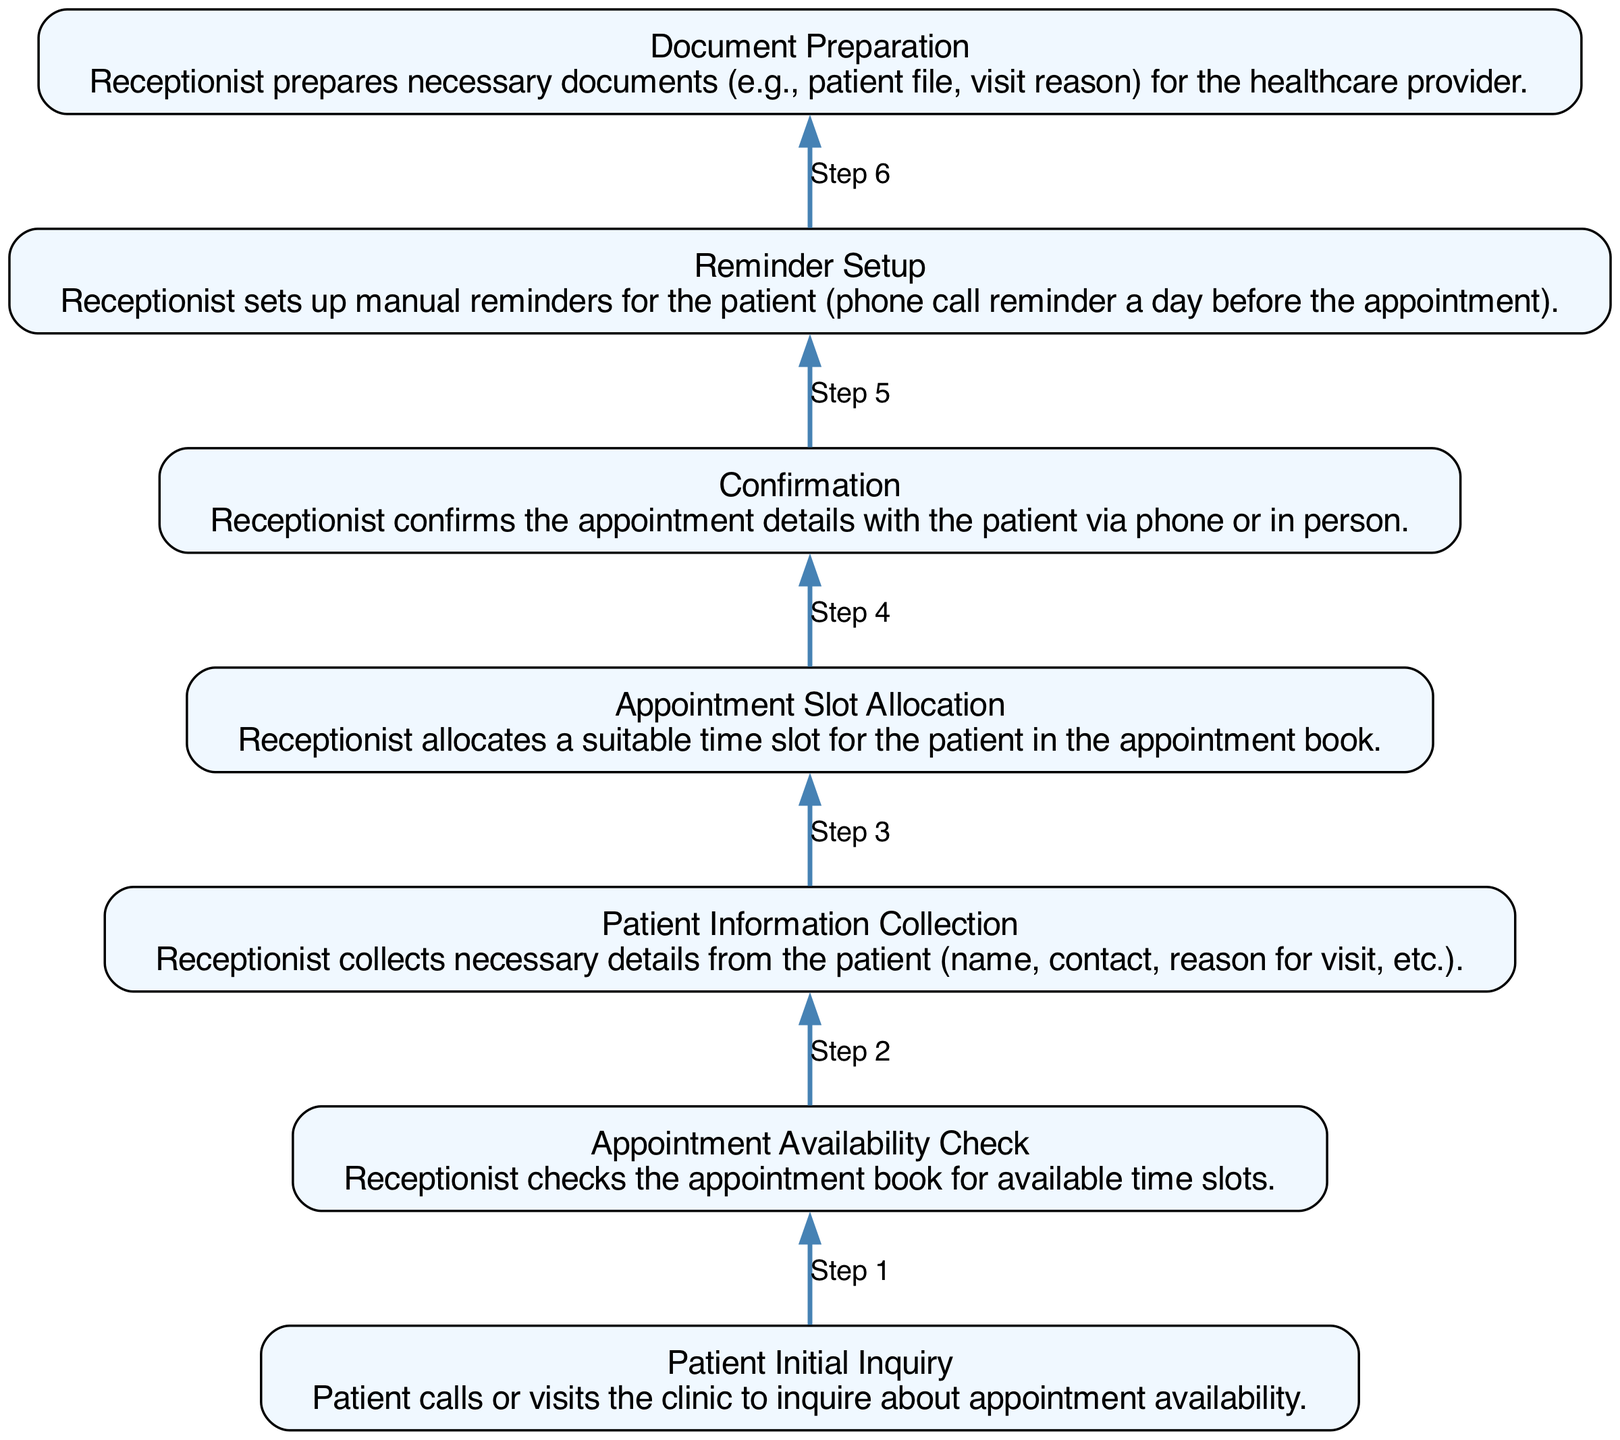What is the first step in the appointment scheduling process? The first step listed in the diagram is "Patient Initial Inquiry," indicating that the process begins with a patient calling or visiting the clinic to check for appointment availability.
Answer: Patient Initial Inquiry How many steps are there in the workflow? The diagram shows a total of 7 steps from the first point of "Patient Initial Inquiry" to the last point of "Document Preparation." Counting them yields 7 distinct steps.
Answer: 7 Which step involves contacting the patient for appointment confirmation? The step labeled "Confirmation" involves the receptionist confirming the appointment details with the patient either by phone or in person, which includes direct communication regarding the appointment.
Answer: Confirmation What comes after noting the appointment details? After noting the appointment details during "Appointment Slot Allocation," the next step is "Confirmation," wherein the receptionist confirms the appointment with the patient.
Answer: Confirmation What is the final step in the process according to the diagram? The final step in the diagram is "Document Preparation," which occurs after confirming the appointment and involves preparing necessary documents for the healthcare provider.
Answer: Document Preparation In which step does the receptionist set up reminders? The step where the receptionist sets up reminders is labeled "Reminder Setup." This involves preparing manual reminders such as a phone call a day prior to the appointment.
Answer: Reminder Setup Based on the flow, what is the relationship between Patient Information Collection and Appointment Slot Allocation? "Patient Information Collection" occurs before "Appointment Slot Allocation," implying that the collection of patient information is necessary before a suitable appointment time can be allocated in the appointment book.
Answer: Patient Information Collection precedes Appointment Slot Allocation Which step involves collecting patient details like name and contact? The step titled "Patient Information Collection" involves the receptionist collecting necessary details from the patient, including their name and contact information, to proceed with the appointment scheduling.
Answer: Patient Information Collection 